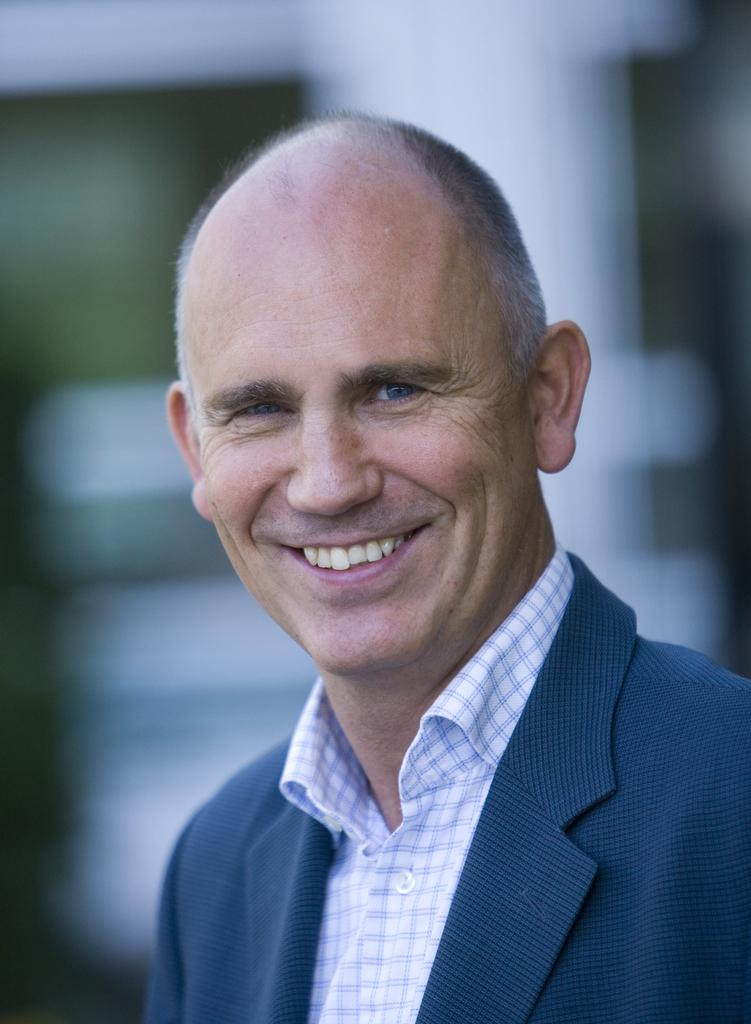What is the man in the image doing? The man is standing in the image. What is the man wearing? The man is wearing a blazer. What expression does the man have? The man is smiling. What can be seen in the background of the image? There is a white object in the background of the image. What division does the man belong to in the image? There is no information about any divisions or organizations in the image, so it cannot be determined. 